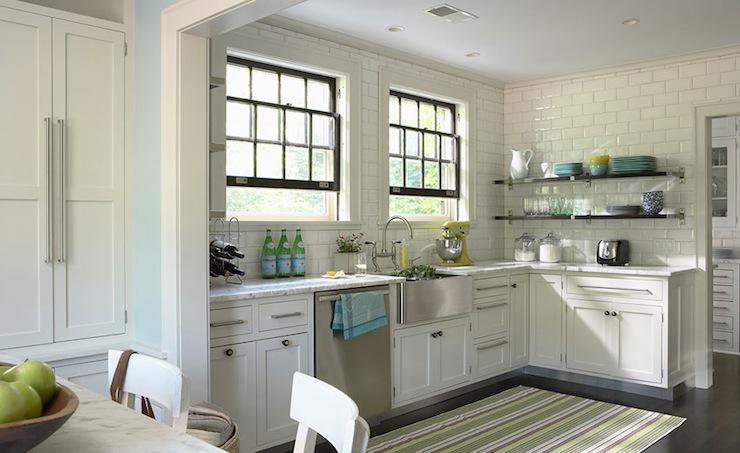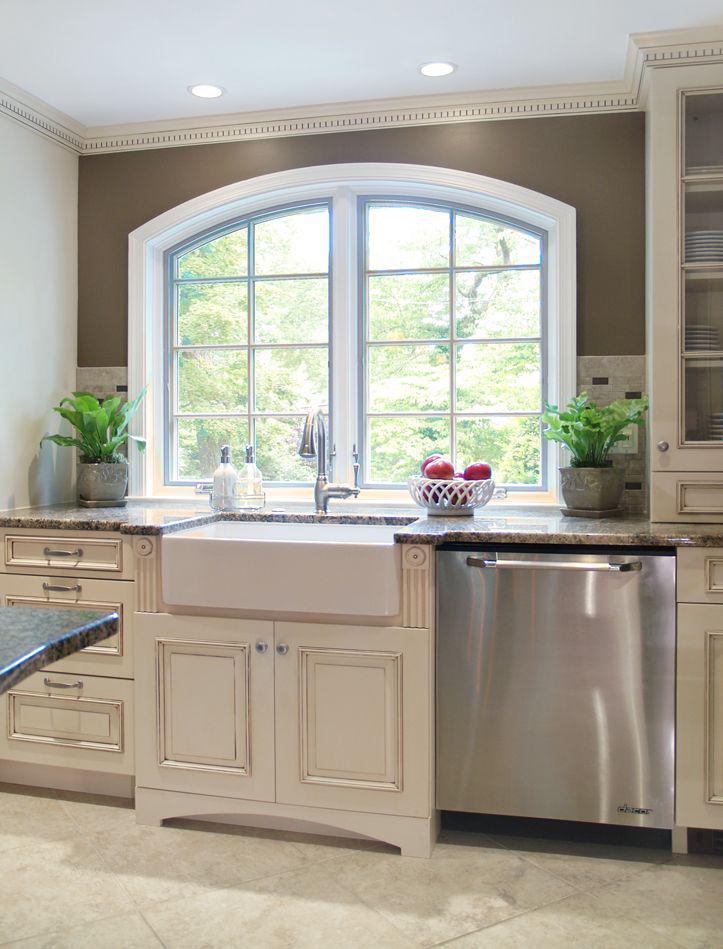The first image is the image on the left, the second image is the image on the right. Given the left and right images, does the statement "In one image, a stainless steel kitchen sink with arc spout is set on a white base cabinet." hold true? Answer yes or no. Yes. The first image is the image on the left, the second image is the image on the right. Analyze the images presented: Is the assertion "An island with a white counter sits in the middle of a kitchen." valid? Answer yes or no. No. 